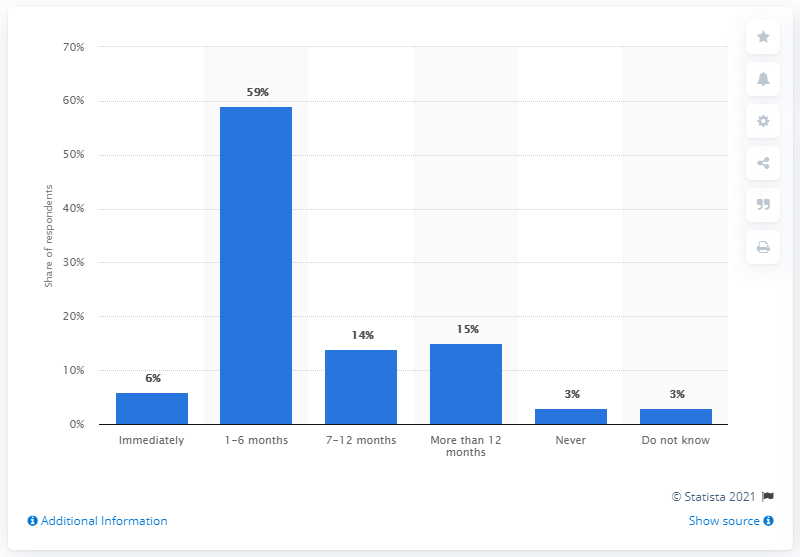Indicate a few pertinent items in this graphic. According to a survey of members of the Danish Employers Association, 59% believe it will take between one and six months to fully recover from the coronavirus outbreak. 